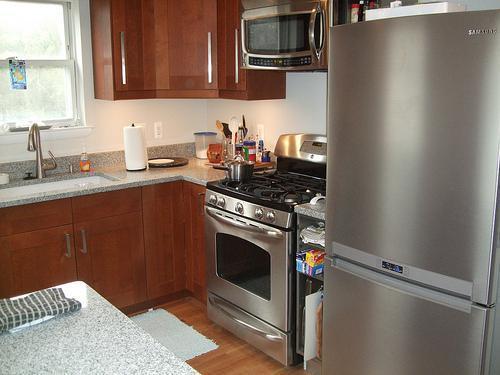How many windows view the outside?
Give a very brief answer. 1. How many blue appliances are there?
Give a very brief answer. 0. 